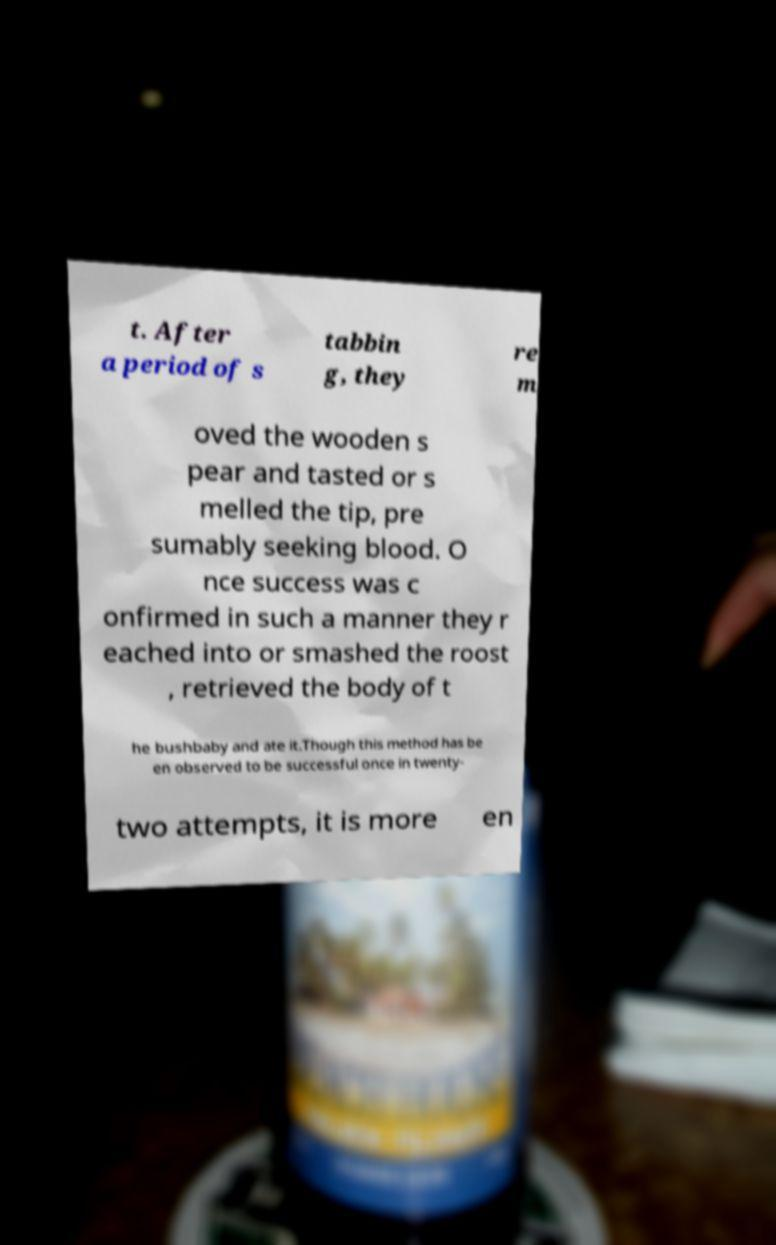Could you extract and type out the text from this image? t. After a period of s tabbin g, they re m oved the wooden s pear and tasted or s melled the tip, pre sumably seeking blood. O nce success was c onfirmed in such a manner they r eached into or smashed the roost , retrieved the body of t he bushbaby and ate it.Though this method has be en observed to be successful once in twenty- two attempts, it is more en 